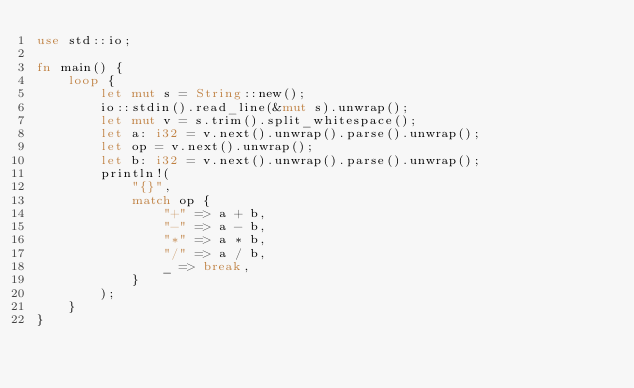Convert code to text. <code><loc_0><loc_0><loc_500><loc_500><_Rust_>use std::io;

fn main() {
    loop {
        let mut s = String::new();
        io::stdin().read_line(&mut s).unwrap();
        let mut v = s.trim().split_whitespace();
        let a: i32 = v.next().unwrap().parse().unwrap();
        let op = v.next().unwrap();
        let b: i32 = v.next().unwrap().parse().unwrap();
        println!(
            "{}",
            match op {
                "+" => a + b,
                "-" => a - b,
                "*" => a * b,
                "/" => a / b,
                _ => break,
            }
        );
    }
}

</code> 